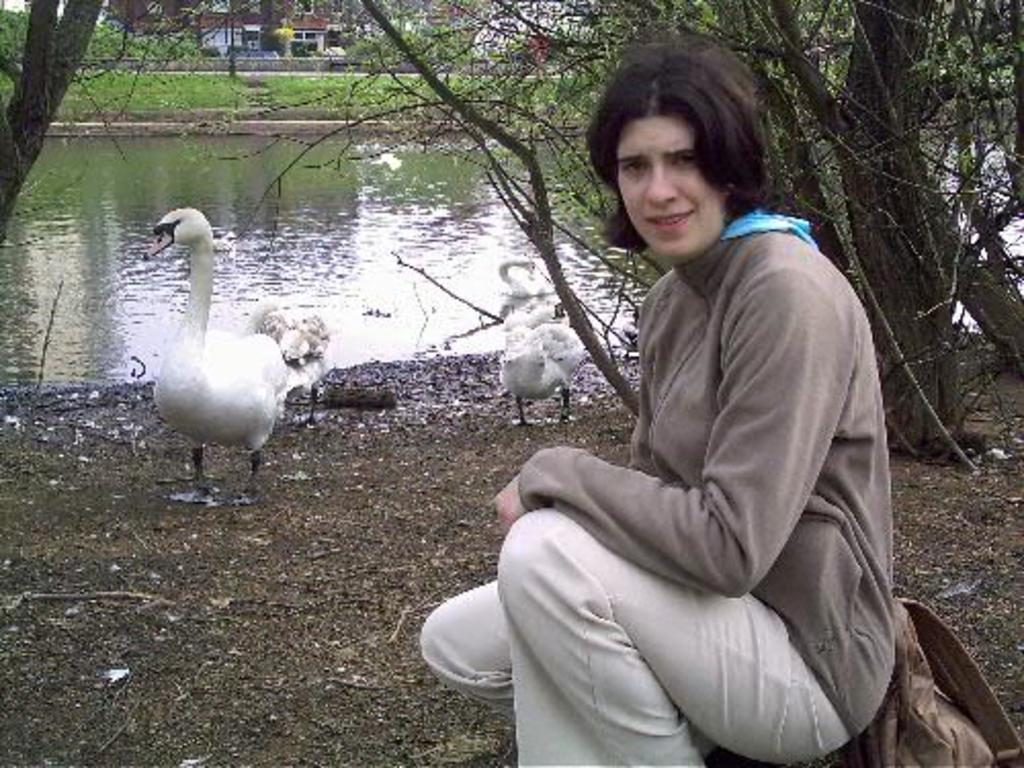Please provide a concise description of this image. In this picture I can see a human and few buildings and trees and I can see few swans in the water and couple of them on the ground and I can see a bag on the ground. 